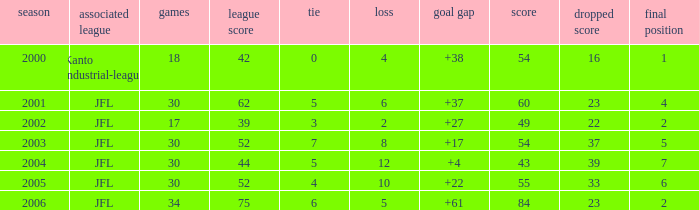Tell me the average final rank for loe more than 10 and point less than 43 None. 